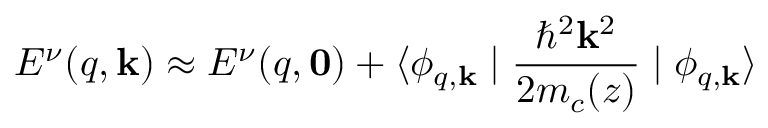<formula> <loc_0><loc_0><loc_500><loc_500>E ^ { \nu } ( q , k ) \approx E ^ { \nu } ( q , 0 ) + \langle \phi _ { q , k } | { \frac { \hbar { ^ } { 2 } k ^ { 2 } } { 2 m _ { c } ( z ) } } | \phi _ { q , k } \rangle</formula> 